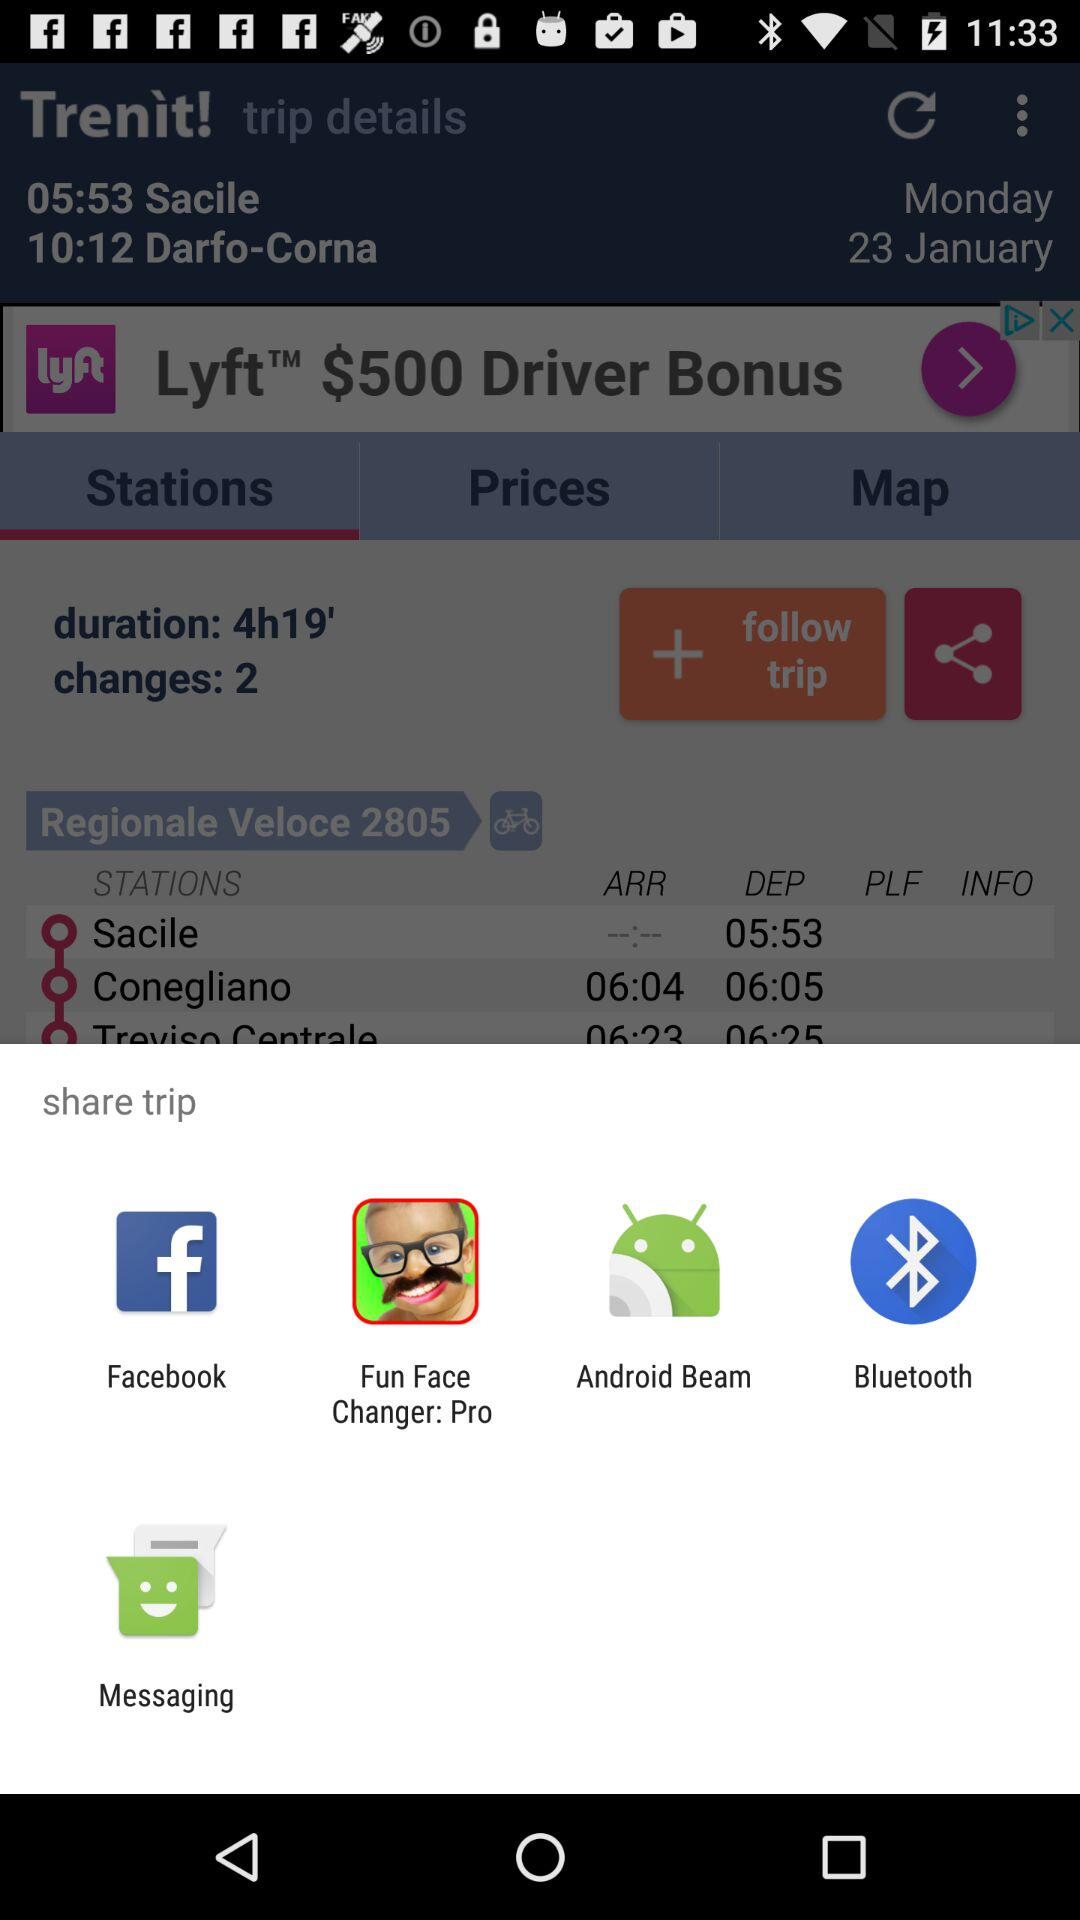How many changes are there in this trip?
Answer the question using a single word or phrase. 2 